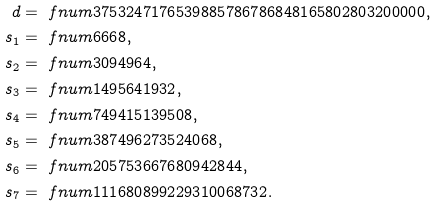Convert formula to latex. <formula><loc_0><loc_0><loc_500><loc_500>d & = \ f n u m { 3 7 5 3 2 4 7 1 7 6 5 3 9 8 8 5 7 8 6 7 8 6 8 4 8 1 6 5 8 0 2 8 0 3 2 0 0 0 0 0 } , \\ s _ { 1 } & = \ f n u m { 6 6 6 8 } , \\ s _ { 2 } & = \ f n u m { 3 0 9 4 9 6 4 } , \\ s _ { 3 } & = \ f n u m { 1 4 9 5 6 4 1 9 3 2 } , \\ s _ { 4 } & = \ f n u m { 7 4 9 4 1 5 1 3 9 5 0 8 } , \\ s _ { 5 } & = \ f n u m { 3 8 7 4 9 6 2 7 3 5 2 4 0 6 8 } , \\ s _ { 6 } & = \ f n u m { 2 0 5 7 5 3 6 6 7 6 8 0 9 4 2 8 4 4 } , \\ s _ { 7 } & = \ f n u m { 1 1 1 6 8 0 8 9 9 2 2 9 3 1 0 0 6 8 7 3 2 } .</formula> 